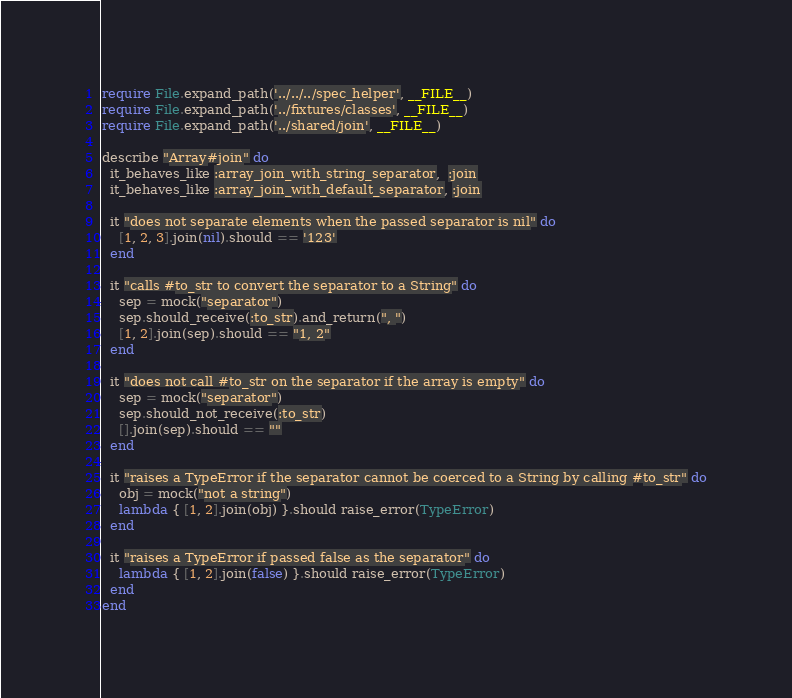<code> <loc_0><loc_0><loc_500><loc_500><_Ruby_>require File.expand_path('../../../spec_helper', __FILE__)
require File.expand_path('../fixtures/classes', __FILE__)
require File.expand_path('../shared/join', __FILE__)

describe "Array#join" do
  it_behaves_like :array_join_with_string_separator,  :join
  it_behaves_like :array_join_with_default_separator, :join

  it "does not separate elements when the passed separator is nil" do
    [1, 2, 3].join(nil).should == '123'
  end

  it "calls #to_str to convert the separator to a String" do
    sep = mock("separator")
    sep.should_receive(:to_str).and_return(", ")
    [1, 2].join(sep).should == "1, 2"
  end

  it "does not call #to_str on the separator if the array is empty" do
    sep = mock("separator")
    sep.should_not_receive(:to_str)
    [].join(sep).should == ""
  end

  it "raises a TypeError if the separator cannot be coerced to a String by calling #to_str" do
    obj = mock("not a string")
    lambda { [1, 2].join(obj) }.should raise_error(TypeError)
  end

  it "raises a TypeError if passed false as the separator" do
    lambda { [1, 2].join(false) }.should raise_error(TypeError)
  end
end
</code> 